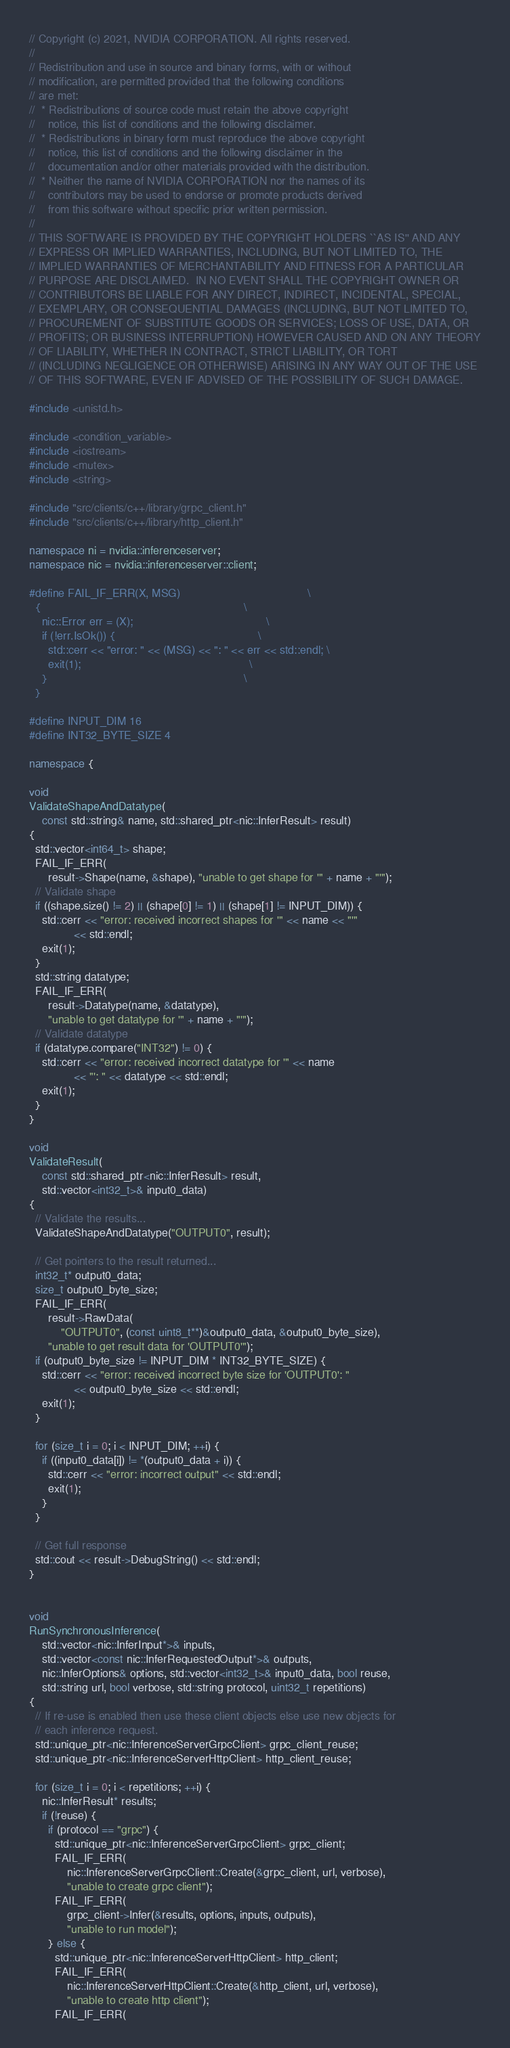Convert code to text. <code><loc_0><loc_0><loc_500><loc_500><_C++_>// Copyright (c) 2021, NVIDIA CORPORATION. All rights reserved.
//
// Redistribution and use in source and binary forms, with or without
// modification, are permitted provided that the following conditions
// are met:
//  * Redistributions of source code must retain the above copyright
//    notice, this list of conditions and the following disclaimer.
//  * Redistributions in binary form must reproduce the above copyright
//    notice, this list of conditions and the following disclaimer in the
//    documentation and/or other materials provided with the distribution.
//  * Neither the name of NVIDIA CORPORATION nor the names of its
//    contributors may be used to endorse or promote products derived
//    from this software without specific prior written permission.
//
// THIS SOFTWARE IS PROVIDED BY THE COPYRIGHT HOLDERS ``AS IS'' AND ANY
// EXPRESS OR IMPLIED WARRANTIES, INCLUDING, BUT NOT LIMITED TO, THE
// IMPLIED WARRANTIES OF MERCHANTABILITY AND FITNESS FOR A PARTICULAR
// PURPOSE ARE DISCLAIMED.  IN NO EVENT SHALL THE COPYRIGHT OWNER OR
// CONTRIBUTORS BE LIABLE FOR ANY DIRECT, INDIRECT, INCIDENTAL, SPECIAL,
// EXEMPLARY, OR CONSEQUENTIAL DAMAGES (INCLUDING, BUT NOT LIMITED TO,
// PROCUREMENT OF SUBSTITUTE GOODS OR SERVICES; LOSS OF USE, DATA, OR
// PROFITS; OR BUSINESS INTERRUPTION) HOWEVER CAUSED AND ON ANY THEORY
// OF LIABILITY, WHETHER IN CONTRACT, STRICT LIABILITY, OR TORT
// (INCLUDING NEGLIGENCE OR OTHERWISE) ARISING IN ANY WAY OUT OF THE USE
// OF THIS SOFTWARE, EVEN IF ADVISED OF THE POSSIBILITY OF SUCH DAMAGE.

#include <unistd.h>

#include <condition_variable>
#include <iostream>
#include <mutex>
#include <string>

#include "src/clients/c++/library/grpc_client.h"
#include "src/clients/c++/library/http_client.h"

namespace ni = nvidia::inferenceserver;
namespace nic = nvidia::inferenceserver::client;

#define FAIL_IF_ERR(X, MSG)                                        \
  {                                                                \
    nic::Error err = (X);                                          \
    if (!err.IsOk()) {                                             \
      std::cerr << "error: " << (MSG) << ": " << err << std::endl; \
      exit(1);                                                     \
    }                                                              \
  }

#define INPUT_DIM 16
#define INT32_BYTE_SIZE 4

namespace {

void
ValidateShapeAndDatatype(
    const std::string& name, std::shared_ptr<nic::InferResult> result)
{
  std::vector<int64_t> shape;
  FAIL_IF_ERR(
      result->Shape(name, &shape), "unable to get shape for '" + name + "'");
  // Validate shape
  if ((shape.size() != 2) || (shape[0] != 1) || (shape[1] != INPUT_DIM)) {
    std::cerr << "error: received incorrect shapes for '" << name << "'"
              << std::endl;
    exit(1);
  }
  std::string datatype;
  FAIL_IF_ERR(
      result->Datatype(name, &datatype),
      "unable to get datatype for '" + name + "'");
  // Validate datatype
  if (datatype.compare("INT32") != 0) {
    std::cerr << "error: received incorrect datatype for '" << name
              << "': " << datatype << std::endl;
    exit(1);
  }
}

void
ValidateResult(
    const std::shared_ptr<nic::InferResult> result,
    std::vector<int32_t>& input0_data)
{
  // Validate the results...
  ValidateShapeAndDatatype("OUTPUT0", result);

  // Get pointers to the result returned...
  int32_t* output0_data;
  size_t output0_byte_size;
  FAIL_IF_ERR(
      result->RawData(
          "OUTPUT0", (const uint8_t**)&output0_data, &output0_byte_size),
      "unable to get result data for 'OUTPUT0'");
  if (output0_byte_size != INPUT_DIM * INT32_BYTE_SIZE) {
    std::cerr << "error: received incorrect byte size for 'OUTPUT0': "
              << output0_byte_size << std::endl;
    exit(1);
  }

  for (size_t i = 0; i < INPUT_DIM; ++i) {
    if ((input0_data[i]) != *(output0_data + i)) {
      std::cerr << "error: incorrect output" << std::endl;
      exit(1);
    }
  }

  // Get full response
  std::cout << result->DebugString() << std::endl;
}


void
RunSynchronousInference(
    std::vector<nic::InferInput*>& inputs,
    std::vector<const nic::InferRequestedOutput*>& outputs,
    nic::InferOptions& options, std::vector<int32_t>& input0_data, bool reuse,
    std::string url, bool verbose, std::string protocol, uint32_t repetitions)
{
  // If re-use is enabled then use these client objects else use new objects for
  // each inference request.
  std::unique_ptr<nic::InferenceServerGrpcClient> grpc_client_reuse;
  std::unique_ptr<nic::InferenceServerHttpClient> http_client_reuse;

  for (size_t i = 0; i < repetitions; ++i) {
    nic::InferResult* results;
    if (!reuse) {
      if (protocol == "grpc") {
        std::unique_ptr<nic::InferenceServerGrpcClient> grpc_client;
        FAIL_IF_ERR(
            nic::InferenceServerGrpcClient::Create(&grpc_client, url, verbose),
            "unable to create grpc client");
        FAIL_IF_ERR(
            grpc_client->Infer(&results, options, inputs, outputs),
            "unable to run model");
      } else {
        std::unique_ptr<nic::InferenceServerHttpClient> http_client;
        FAIL_IF_ERR(
            nic::InferenceServerHttpClient::Create(&http_client, url, verbose),
            "unable to create http client");
        FAIL_IF_ERR(</code> 